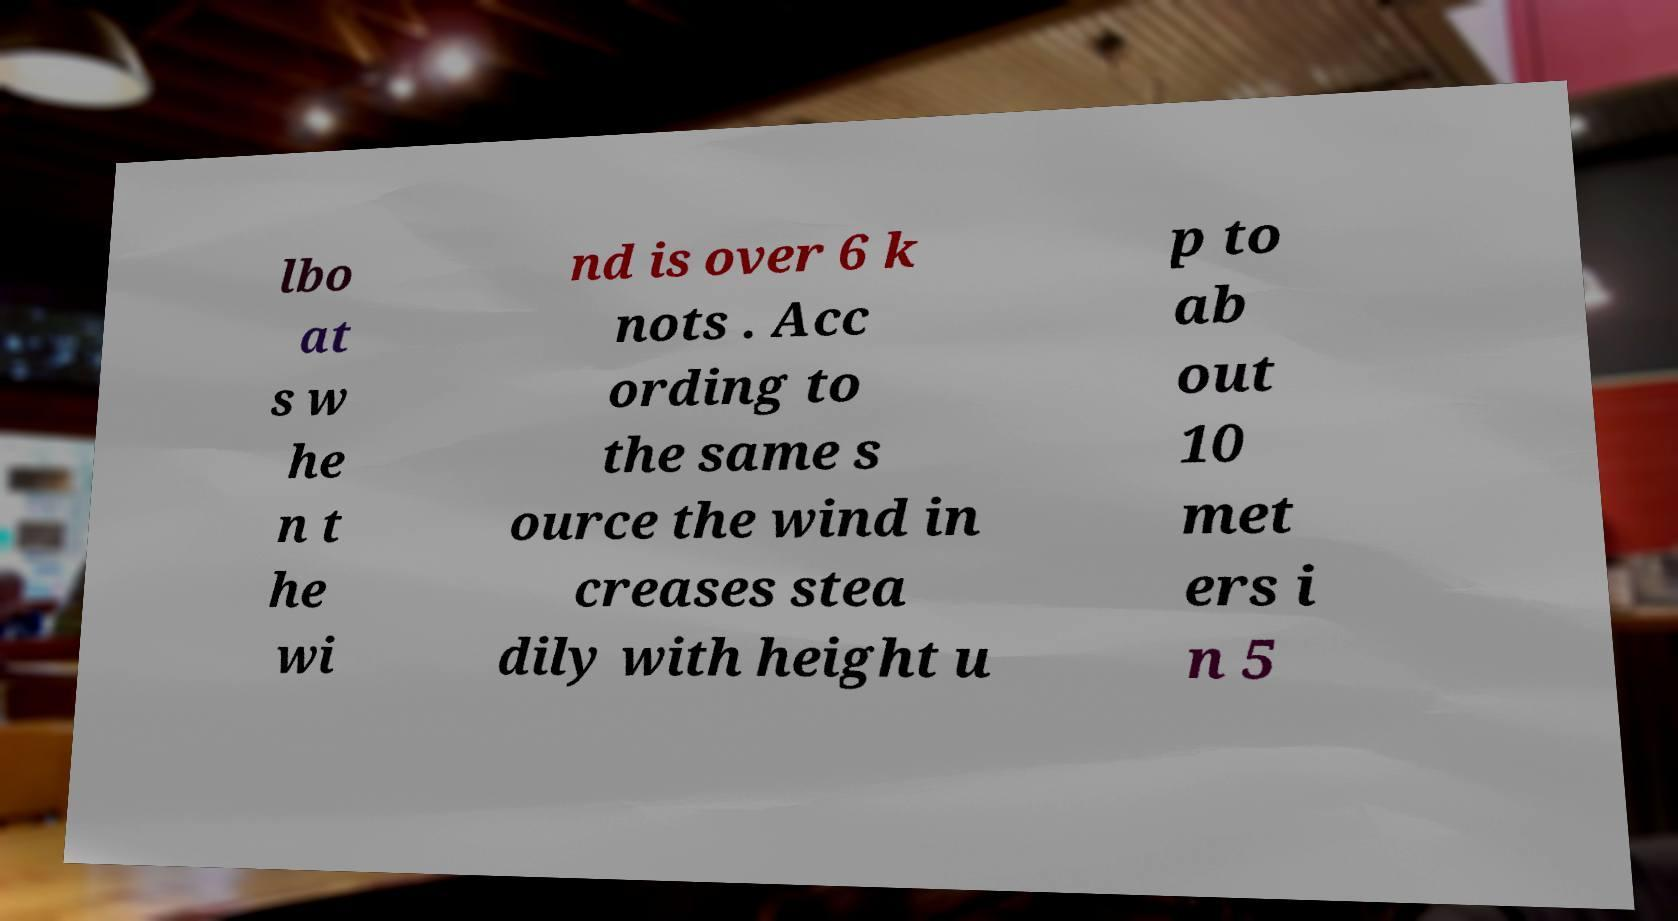Can you accurately transcribe the text from the provided image for me? lbo at s w he n t he wi nd is over 6 k nots . Acc ording to the same s ource the wind in creases stea dily with height u p to ab out 10 met ers i n 5 